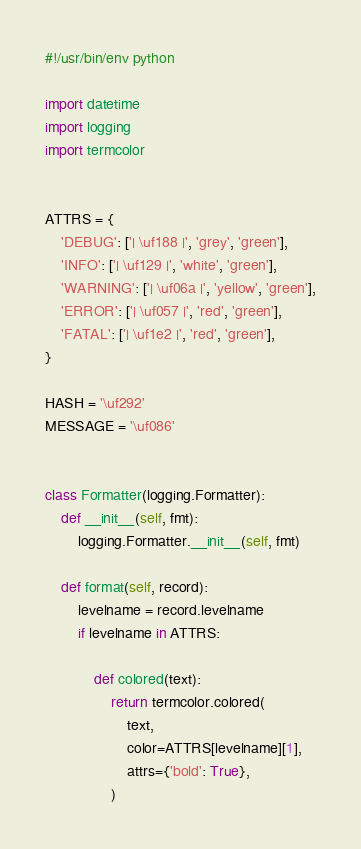Convert code to text. <code><loc_0><loc_0><loc_500><loc_500><_Python_>#!/usr/bin/env python

import datetime
import logging
import termcolor


ATTRS = {
    'DEBUG': ['| \uf188 |', 'grey', 'green'],
    'INFO': ['| \uf129 |', 'white', 'green'],
    'WARNING': ['| \uf06a |', 'yellow', 'green'],
    'ERROR': ['| \uf057 |', 'red', 'green'],
    'FATAL': ['| \uf1e2 |', 'red', 'green'],
}

HASH = '\uf292'
MESSAGE = '\uf086'


class Formatter(logging.Formatter):
    def __init__(self, fmt):
        logging.Formatter.__init__(self, fmt)

    def format(self, record):
        levelname = record.levelname
        if levelname in ATTRS:

            def colored(text):
                return termcolor.colored(
                    text,
                    color=ATTRS[levelname][1],
                    attrs={'bold': True},
                )
</code> 